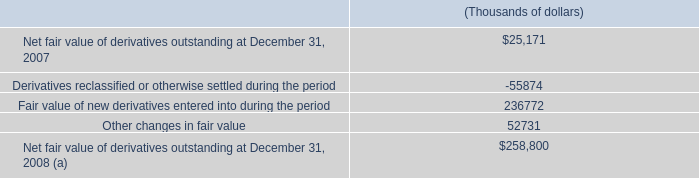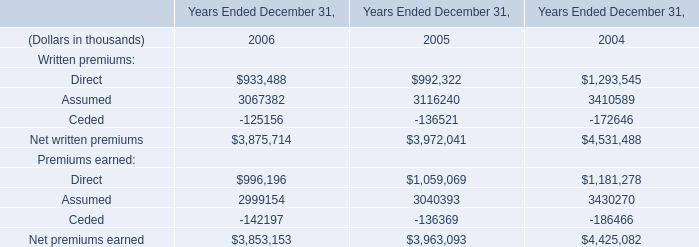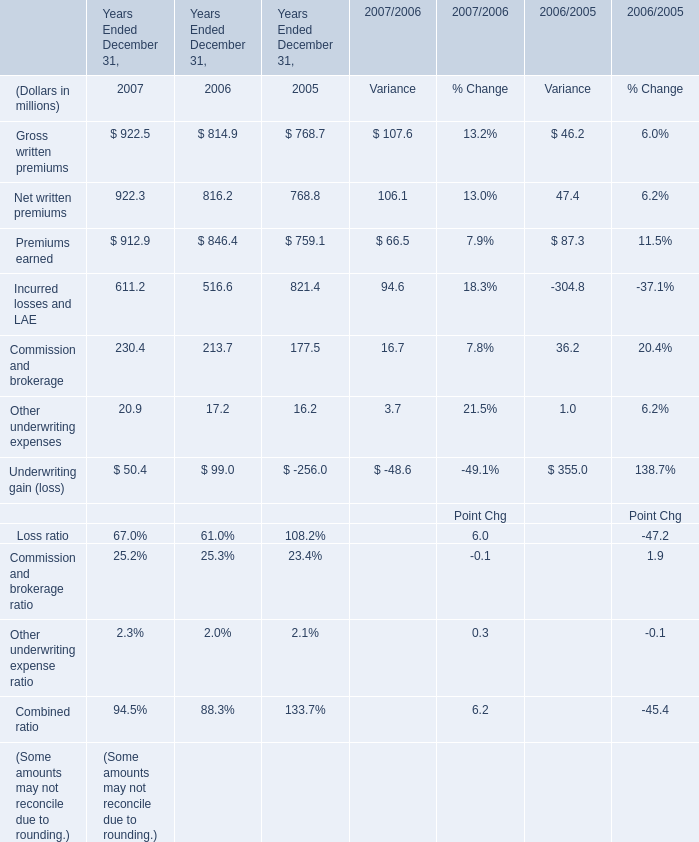As As the chart 2 shows,what is the sum of the Premiums earned in 2005 Ended December 31? (in million) 
Answer: 759.1. 